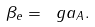Convert formula to latex. <formula><loc_0><loc_0><loc_500><loc_500>\beta _ { e } = \ g a _ { A } .</formula> 